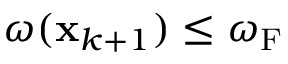Convert formula to latex. <formula><loc_0><loc_0><loc_500><loc_500>\omega ( { x } _ { k + 1 } ) \leq \omega _ { F }</formula> 